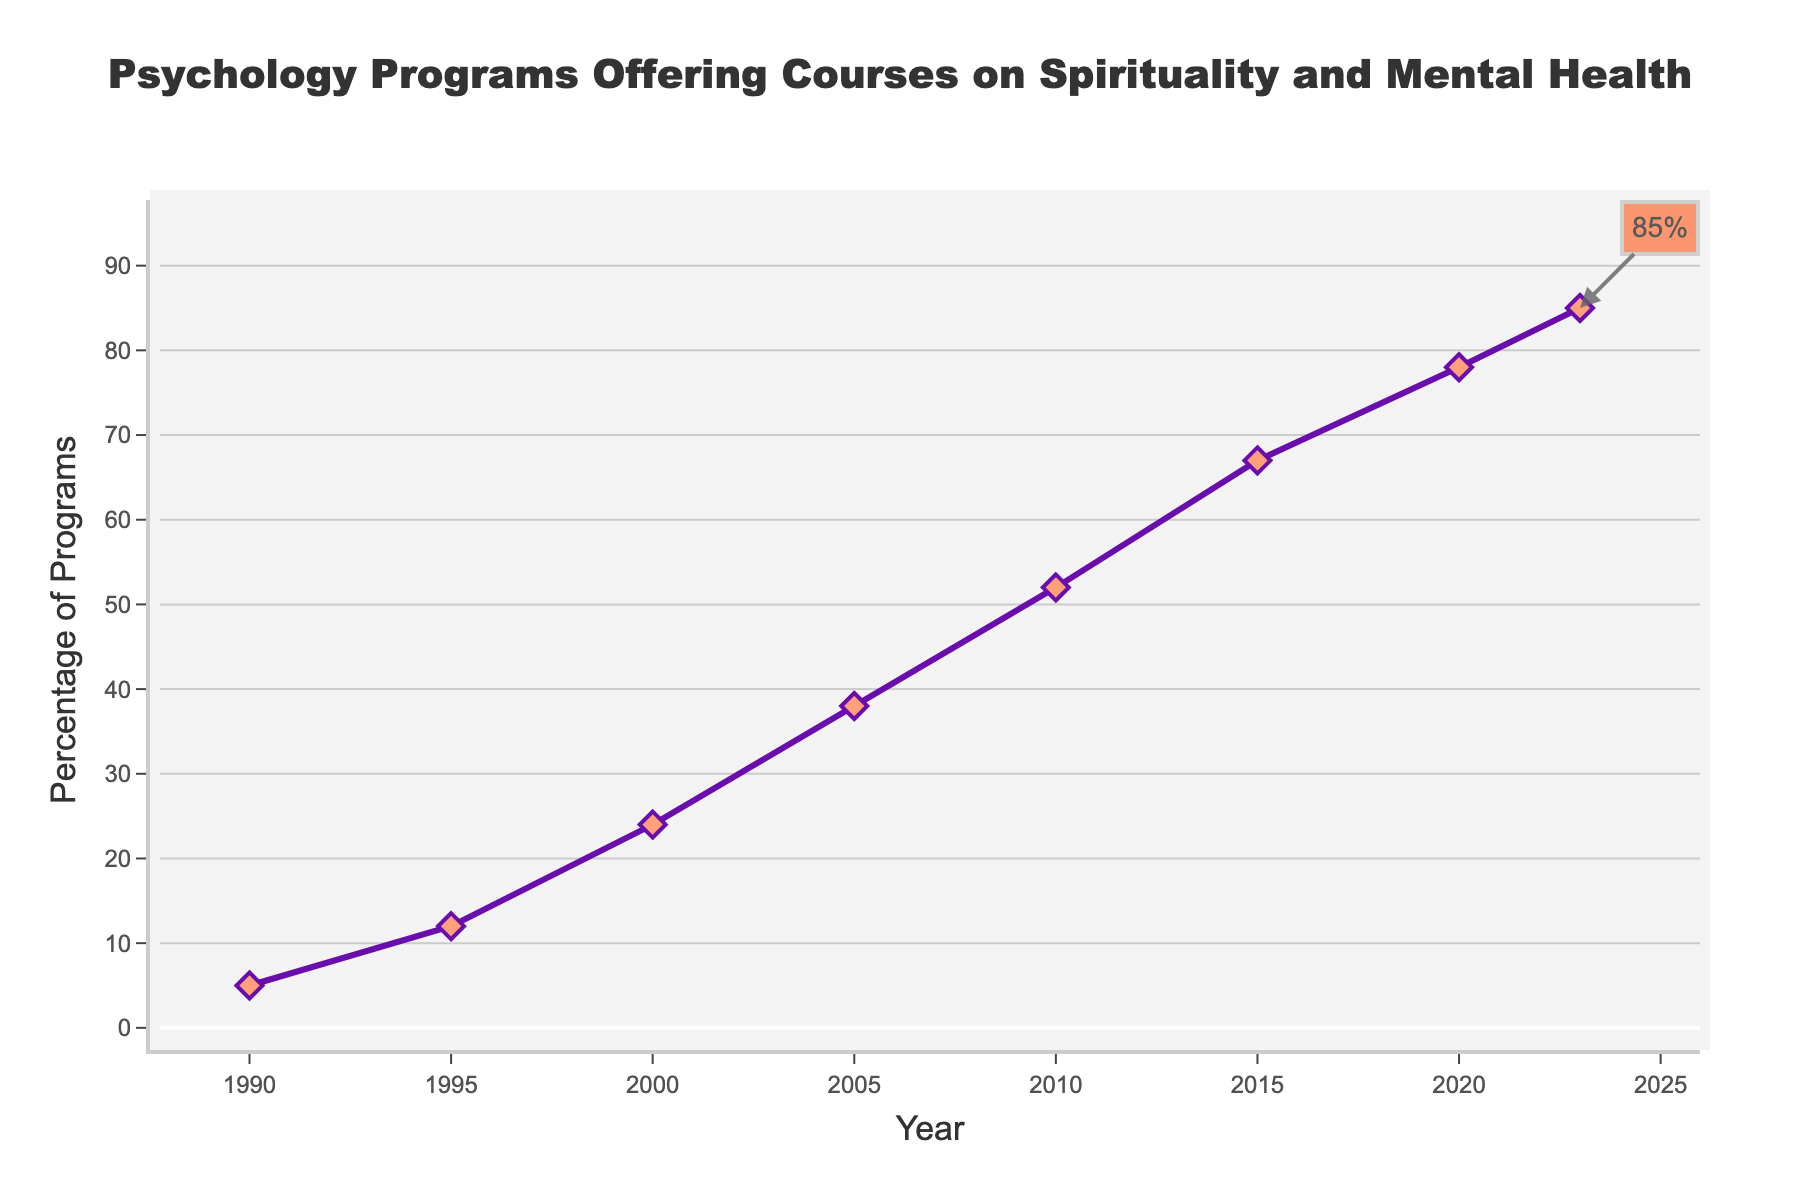What was the percentage of psychology programs offering courses on spirituality and mental health in 2000? Look at the data point on the line chart corresponding to the year 2000.
Answer: 24 Between which years did the percentage increase the fastest? Compare the steepness of the line segments between consecutive years. The steepest increase happened between 2000 and 2005.
Answer: 2000 and 2005 What is the difference in the percentage of programs offering these courses between 1990 and 2023? Subtract the percentage in 1990 from the percentage in 2023: 85 - 5 = 80.
Answer: 80 Looking at the overall trend from 1990 to 2023, how would you describe the change in the percentage of programs offering courses? The trend shows a consistent and significant increase in the percentage over the years.
Answer: Consistent and significant increase In which year did the percentage first exceed 50%? Identify the year when the percentage first goes beyond 50%, which is shown at the data point for 2010.
Answer: 2010 By what percentage did the offerings increase from 1995 to 2000? Subtract the 1995 percentage from the 2000 percentage: 24 - 12 = 12%.
Answer: 12 How does the increase from 2015 to 2023 compare to the increase from 2005 to 2015? Calculate the difference for both periods: 2023 - 2015 (85 - 67 = 18) and 2015 - 2005 (67 - 38 = 29). Compare the two differences.
Answer: The increase from 2005 to 2015 is larger What is the average percentage of programs offering courses from 1990 to 2023? Sum all the percentage values and divide by the number of data points: (5 + 12 + 24 + 38 + 52 + 67 + 78 + 85) / 8 = 44.625.
Answer: 44.625 Was there any year when the percentage did not increase compared to the previous data point? Check for any year where the percentage remains the same or decreases compared to the previous year. In this chart, every year shows an increase.
Answer: No 